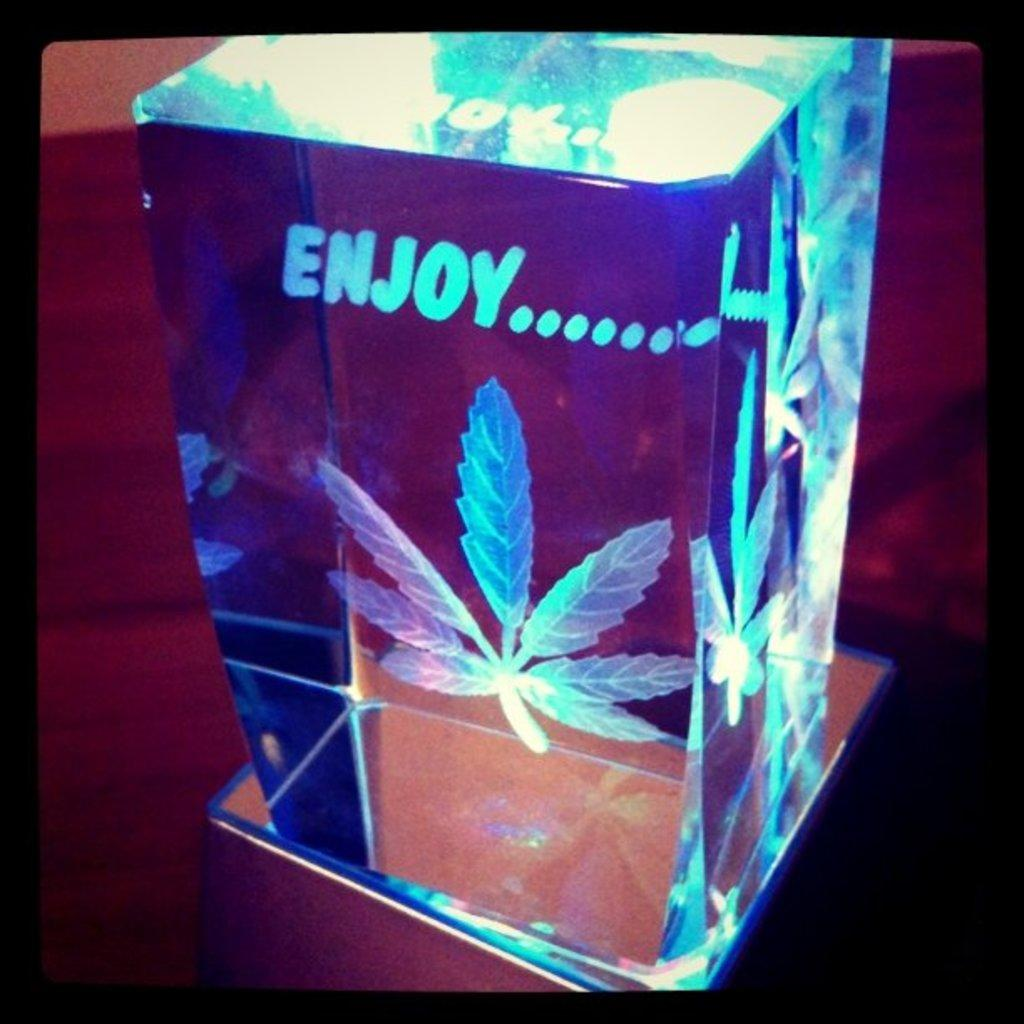What is the main subject in the foreground of the image? There is a cube in the foreground of the image. What is inside the cube? There is an art piece inside the cube. Where are the cube and the art piece placed? Both the cube and the art piece are placed on a surface. Can you see any crackers near the cube in the image? There is no mention of crackers in the image, so it cannot be determined if any are present. How many feet are visible in the image? There is no mention of feet in the image, so it cannot be determined if any are visible. 